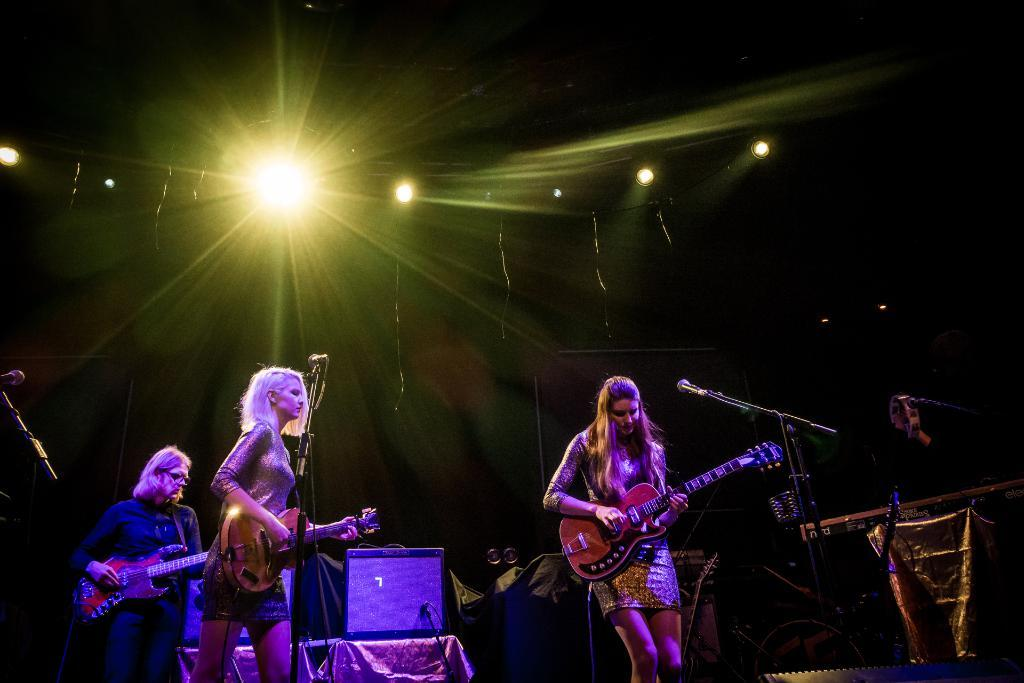How many people are in the image? There are three girls in the image. What are the girls doing in the image? The girls are performing musical actions. Which girl is playing a specific musical instrument? One girl is playing the guitar. What equipment is present for amplifying sound? There is a microphone in the image. Can you describe the lighting conditions in the image? There is light in the image. What type of bird is singing on the team's guide in the image? There is no bird, team, or guide present in the image. 